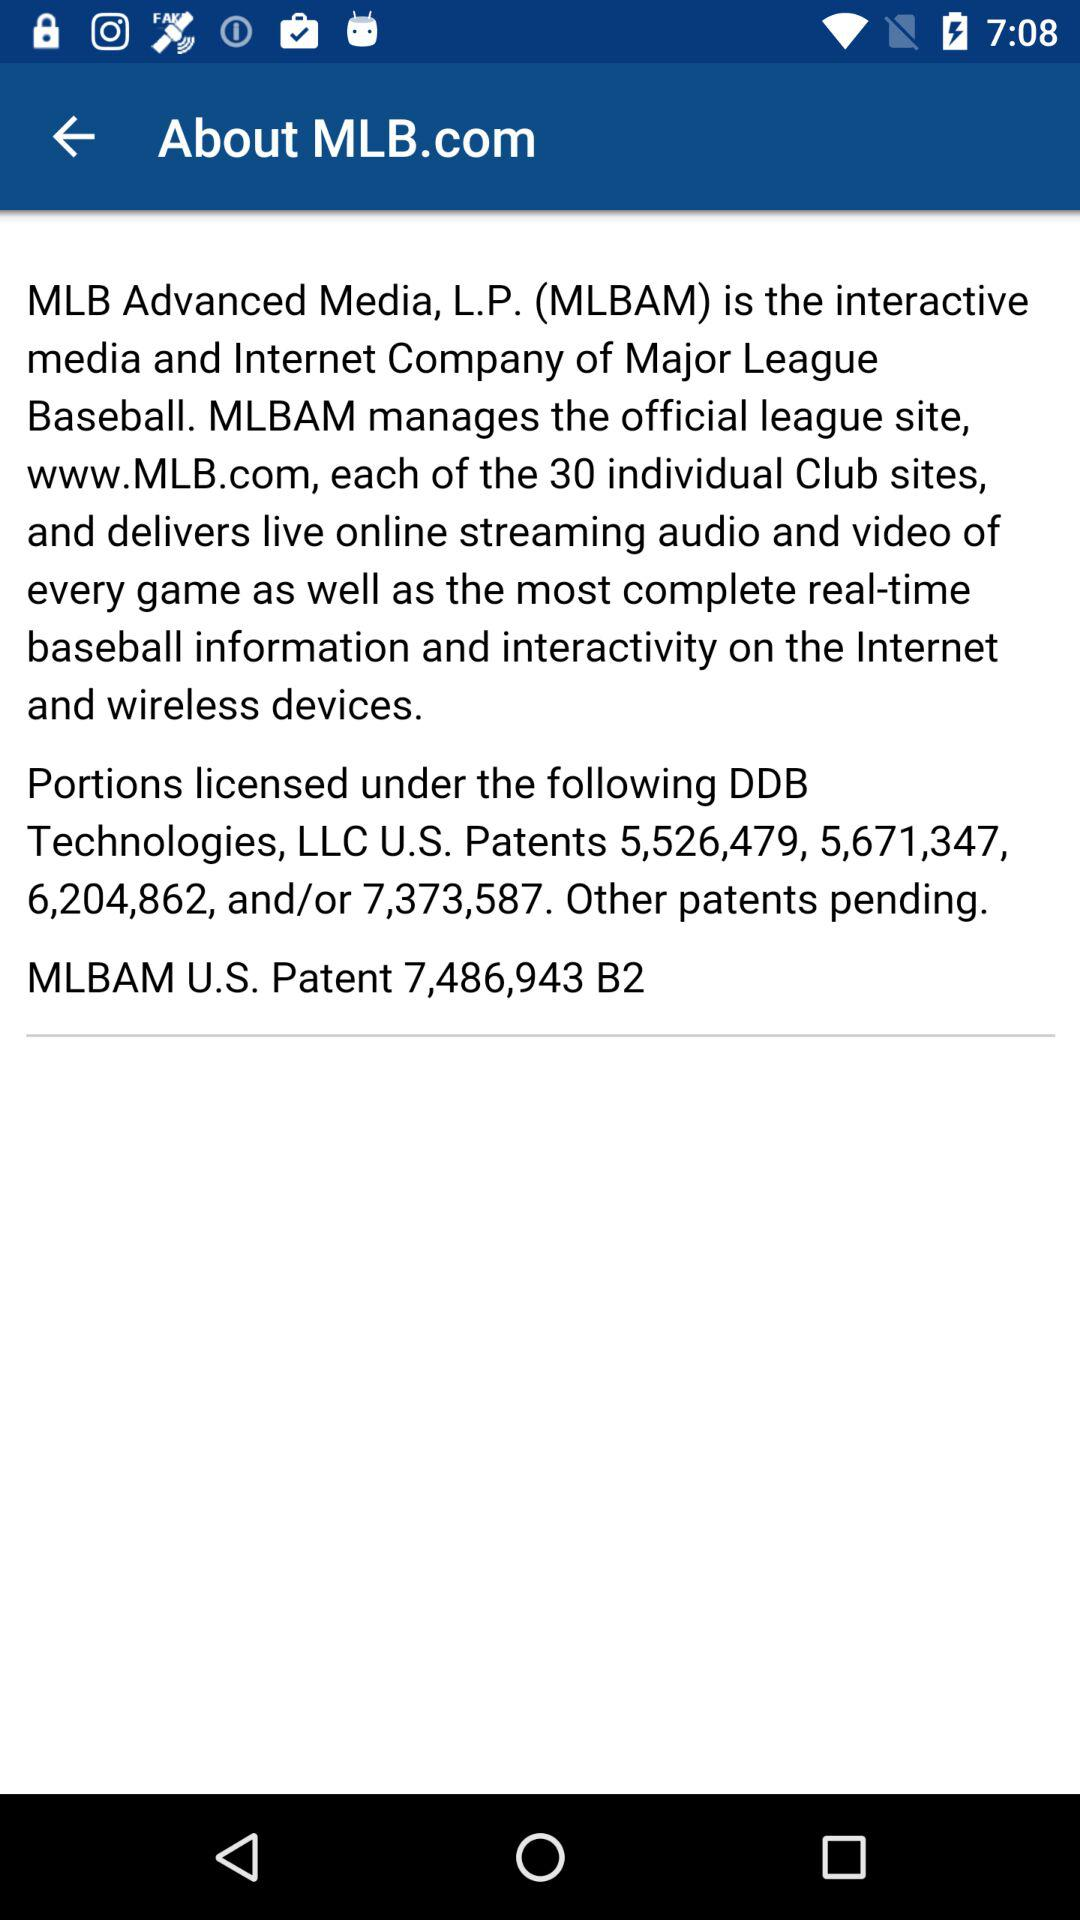What is "MLB Advanced Media"? "MLB Advanced Media" is the interactive media and Internet Company of Major League Baseball. 